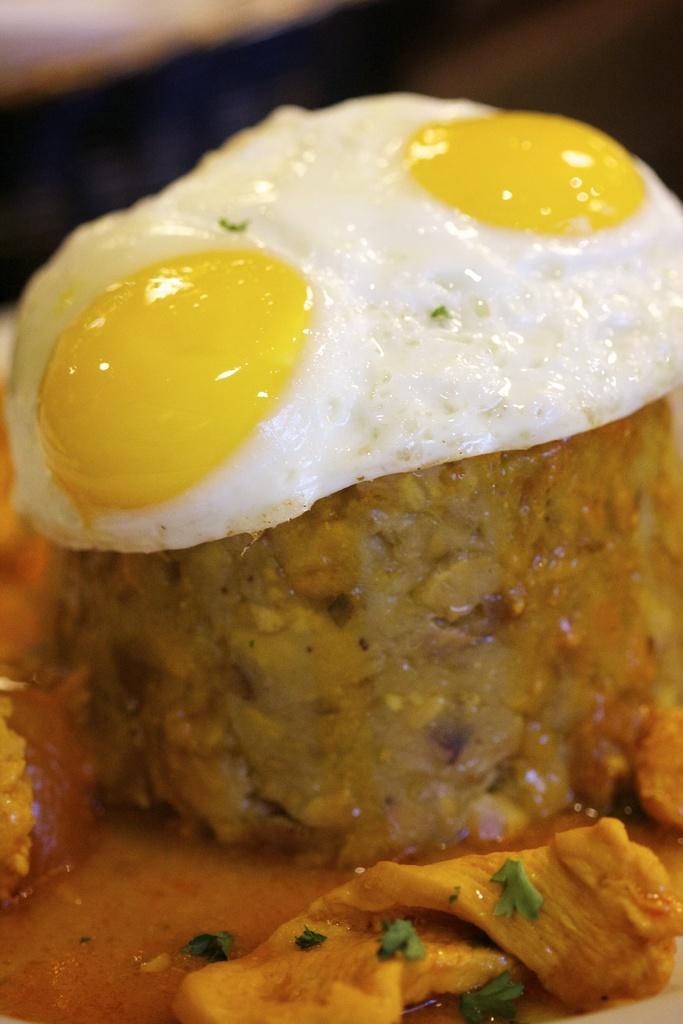Can you describe this image briefly? In this image we can see poached egg and food. 